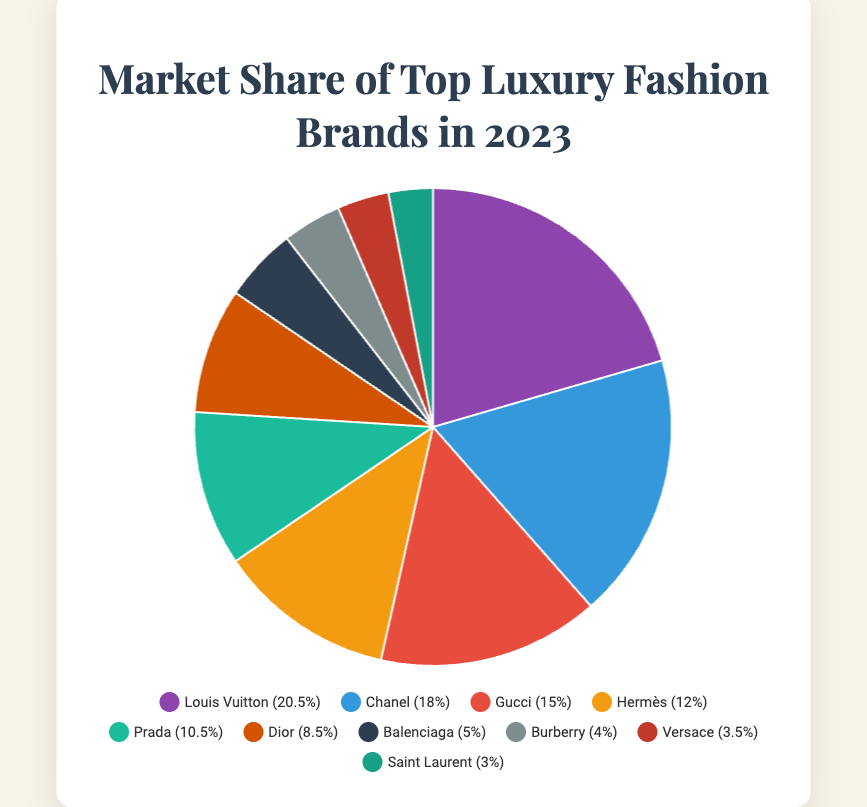What is the market share difference between Louis Vuitton and Chanel? Louis Vuitton's market share is 20.5% and Chanel's is 18.0%. The difference is calculated as 20.5% - 18.0% = 2.5%.
Answer: 2.5% Which brand holds the third-largest market share? The brands are listed in descending order of market share: Louis Vuitton, Chanel, Gucci, Hermès, Prada, Dior, Balenciaga, Burberry, Versace, and Saint Laurent. The third brand is Gucci at 15.0%.
Answer: Gucci What is the combined market share of Prada, Dior, and Balenciaga? Adding up the market shares of Prada (10.5%), Dior (8.5%), and Balenciaga (5.0%) gives 10.5% + 8.5% + 5.0% = 24.0%.
Answer: 24.0% Compare the market share of Hermès and Burberry. Hermès has a market share of 12.0%, and Burberry has a market share of 4.0%. Hermès holds a greater share than Burberry.
Answer: Hermès What is the total market share of brands holding less than 5%? The brands holding less than 5% are Balenciaga (5.0% not included as it’s exactly 5%), Burberry (4.0%), Versace (3.5%), and Saint Laurent (3.0%). Adding them gives 4.0% + 3.5% + 3.0% = 10.5%.
Answer: 10.5% Which brand is represented by the darkest color in the pie chart? The color scheme typically goes from dark to light in a pie chart. The darkest color represents Louis Vuitton, which has the largest market share of 20.5%.
Answer: Louis Vuitton Is the market share of Louis Vuitton more than twice that of Versace? Louis Vuitton's market share is 20.5%, and Versace's is 3.5%. Twice the market share of Versace would be 3.5% * 2 = 7.0%. Since 20.5% > 7.0%, Louis Vuitton's share is indeed more than twice that of Versace.
Answer: Yes Calculate the average market share of the top 5 brands. The top 5 brands are Louis Vuitton (20.5%), Chanel (18.0%), Gucci (15.0%), Hermès (12.0%), and Prada (10.5%). The average is calculated by (20.5% + 18.0% + 15.0% + 12.0% + 10.5%) / 5 = 76.0% / 5 = 15.2%.
Answer: 15.2% Which brands have a market share that is equal or greater than the average market share of all the brands in the pie chart? The sum of all market shares is 100%. With 10 brands, the average is 100% / 10 = 10%. Brands with market shares equal or greater than the average are Louis Vuitton (20.5%), Chanel (18.0%), Gucci (15.0%), Hermès (12.0%), and Prada (10.5%).
Answer: Louis Vuitton, Chanel, Gucci, Hermès, Prada 